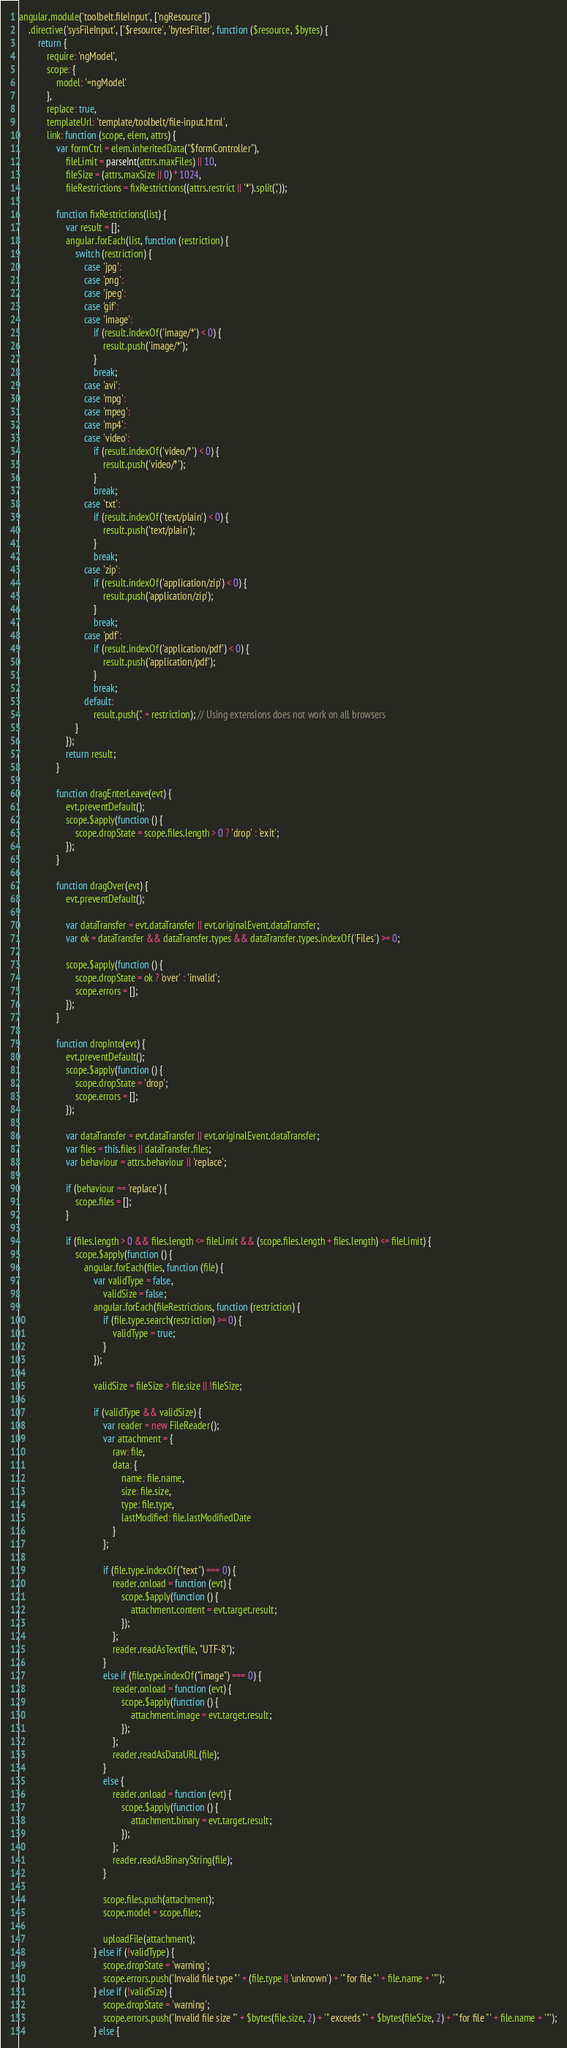Convert code to text. <code><loc_0><loc_0><loc_500><loc_500><_JavaScript_>angular.module('toolbelt.fileInput', ['ngResource'])
    .directive('sysFileInput', ['$resource', 'bytesFilter', function ($resource, $bytes) {
        return {
            require: 'ngModel',
            scope: {
                model: '=ngModel'
            },
            replace: true,
            templateUrl: 'template/toolbelt/file-input.html',
            link: function (scope, elem, attrs) {
                var formCtrl = elem.inheritedData("$formController"),
                    fileLimit = parseInt(attrs.maxFiles) || 10,
                    fileSize = (attrs.maxSize || 0) * 1024,
                    fileRestrictions = fixRestrictions((attrs.restrict || '*').split(','));

                function fixRestrictions(list) {
                    var result = [];
                    angular.forEach(list, function (restriction) {
                        switch (restriction) {
                            case 'jpg':
                            case 'png':
                            case 'jpeg':
                            case 'gif':
                            case 'image':
                                if (result.indexOf('image/*') < 0) {
                                    result.push('image/*');
                                }
                                break;
                            case 'avi':
                            case 'mpg':
                            case 'mpeg':
                            case 'mp4':
                            case 'video':
                                if (result.indexOf('video/*') < 0) {
                                    result.push('video/*');
                                }
                                break;
                            case 'txt':
                                if (result.indexOf('text/plain') < 0) {
                                    result.push('text/plain');
                                }
                                break;
                            case 'zip':
                                if (result.indexOf('application/zip') < 0) {
                                    result.push('application/zip');
                                }
                                break;
                            case 'pdf':
                                if (result.indexOf('application/pdf') < 0) {
                                    result.push('application/pdf');
                                }
                                break;
                            default:
                                result.push('.' + restriction); // Using extensions does not work on all browsers
                        }
                    });
                    return result;
                }

                function dragEnterLeave(evt) {
                    evt.preventDefault();
                    scope.$apply(function () {
                        scope.dropState = scope.files.length > 0 ? 'drop' : 'exit';
                    });
                }

                function dragOver(evt) {
                    evt.preventDefault();

                    var dataTransfer = evt.dataTransfer || evt.originalEvent.dataTransfer;
                    var ok = dataTransfer && dataTransfer.types && dataTransfer.types.indexOf('Files') >= 0;

                    scope.$apply(function () {
                        scope.dropState = ok ? 'over' : 'invalid';
                        scope.errors = [];
                    });
                }

                function dropInto(evt) {
                    evt.preventDefault();
                    scope.$apply(function () {
                        scope.dropState = 'drop';
                        scope.errors = [];
                    });

                    var dataTransfer = evt.dataTransfer || evt.originalEvent.dataTransfer;
                    var files = this.files || dataTransfer.files;
                    var behaviour = attrs.behaviour || 'replace';

                    if (behaviour == 'replace') {
                        scope.files = [];
                    }

                    if (files.length > 0 && files.length <= fileLimit && (scope.files.length + files.length) <= fileLimit) {
                        scope.$apply(function () {
                            angular.forEach(files, function (file) {
                                var validType = false,
                                    validSize = false;
                                angular.forEach(fileRestrictions, function (restriction) {
                                    if (file.type.search(restriction) >= 0) {
                                        validType = true;
                                    }
                                });

                                validSize = fileSize > file.size || !fileSize;

                                if (validType && validSize) {
                                    var reader = new FileReader();
                                    var attachment = {
                                        raw: file,
                                        data: {
                                            name: file.name,
                                            size: file.size,
                                            type: file.type,
                                            lastModified: file.lastModifiedDate
                                        }
                                    };

                                    if (file.type.indexOf("text") === 0) {
                                        reader.onload = function (evt) {
                                            scope.$apply(function () {
                                                attachment.content = evt.target.result;
                                            });
                                        };
                                        reader.readAsText(file, "UTF-8");
                                    }
                                    else if (file.type.indexOf("image") === 0) {
                                        reader.onload = function (evt) {
                                            scope.$apply(function () {
                                                attachment.image = evt.target.result;
                                            });
                                        };
                                        reader.readAsDataURL(file);
                                    }
                                    else {
                                        reader.onload = function (evt) {
                                            scope.$apply(function () {
                                                attachment.binary = evt.target.result;
                                            });
                                        };
                                        reader.readAsBinaryString(file);
                                    }

                                    scope.files.push(attachment);
                                    scope.model = scope.files;

                                    uploadFile(attachment);
                                } else if (!validType) {
                                    scope.dropState = 'warning';
                                    scope.errors.push('Invalid file type "' + (file.type || 'unknown') + '" for file "' + file.name + '"');
                                } else if (!validSize) {
                                    scope.dropState = 'warning';
                                    scope.errors.push('Invalid file size "' + $bytes(file.size, 2) + '" exceeds "' + $bytes(fileSize, 2) + '" for file "' + file.name + '"');
                                } else {</code> 